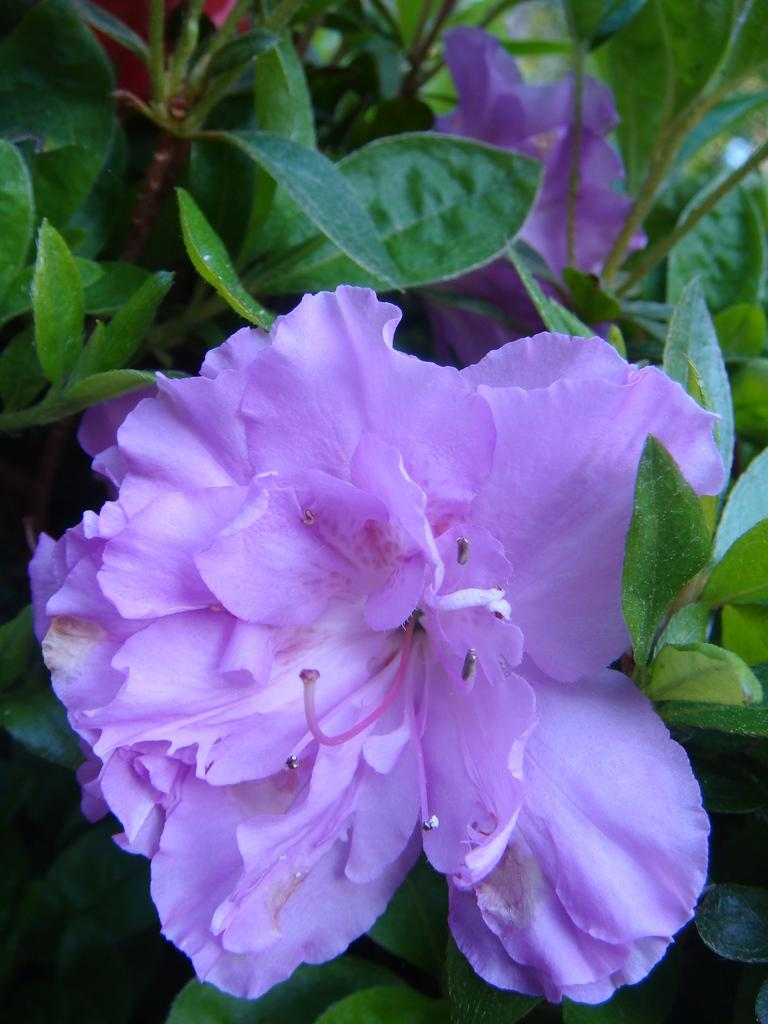What type of plant parts can be seen in the image? There are flowers, leaves, and stems in the image. How many ladybugs can be seen on the flowers in the image? There are no ladybugs present in the image; it only features flowers, leaves, and stems. What message of hope can be read from the image? The image does not contain any text or symbolism that conveys a message of hope. 